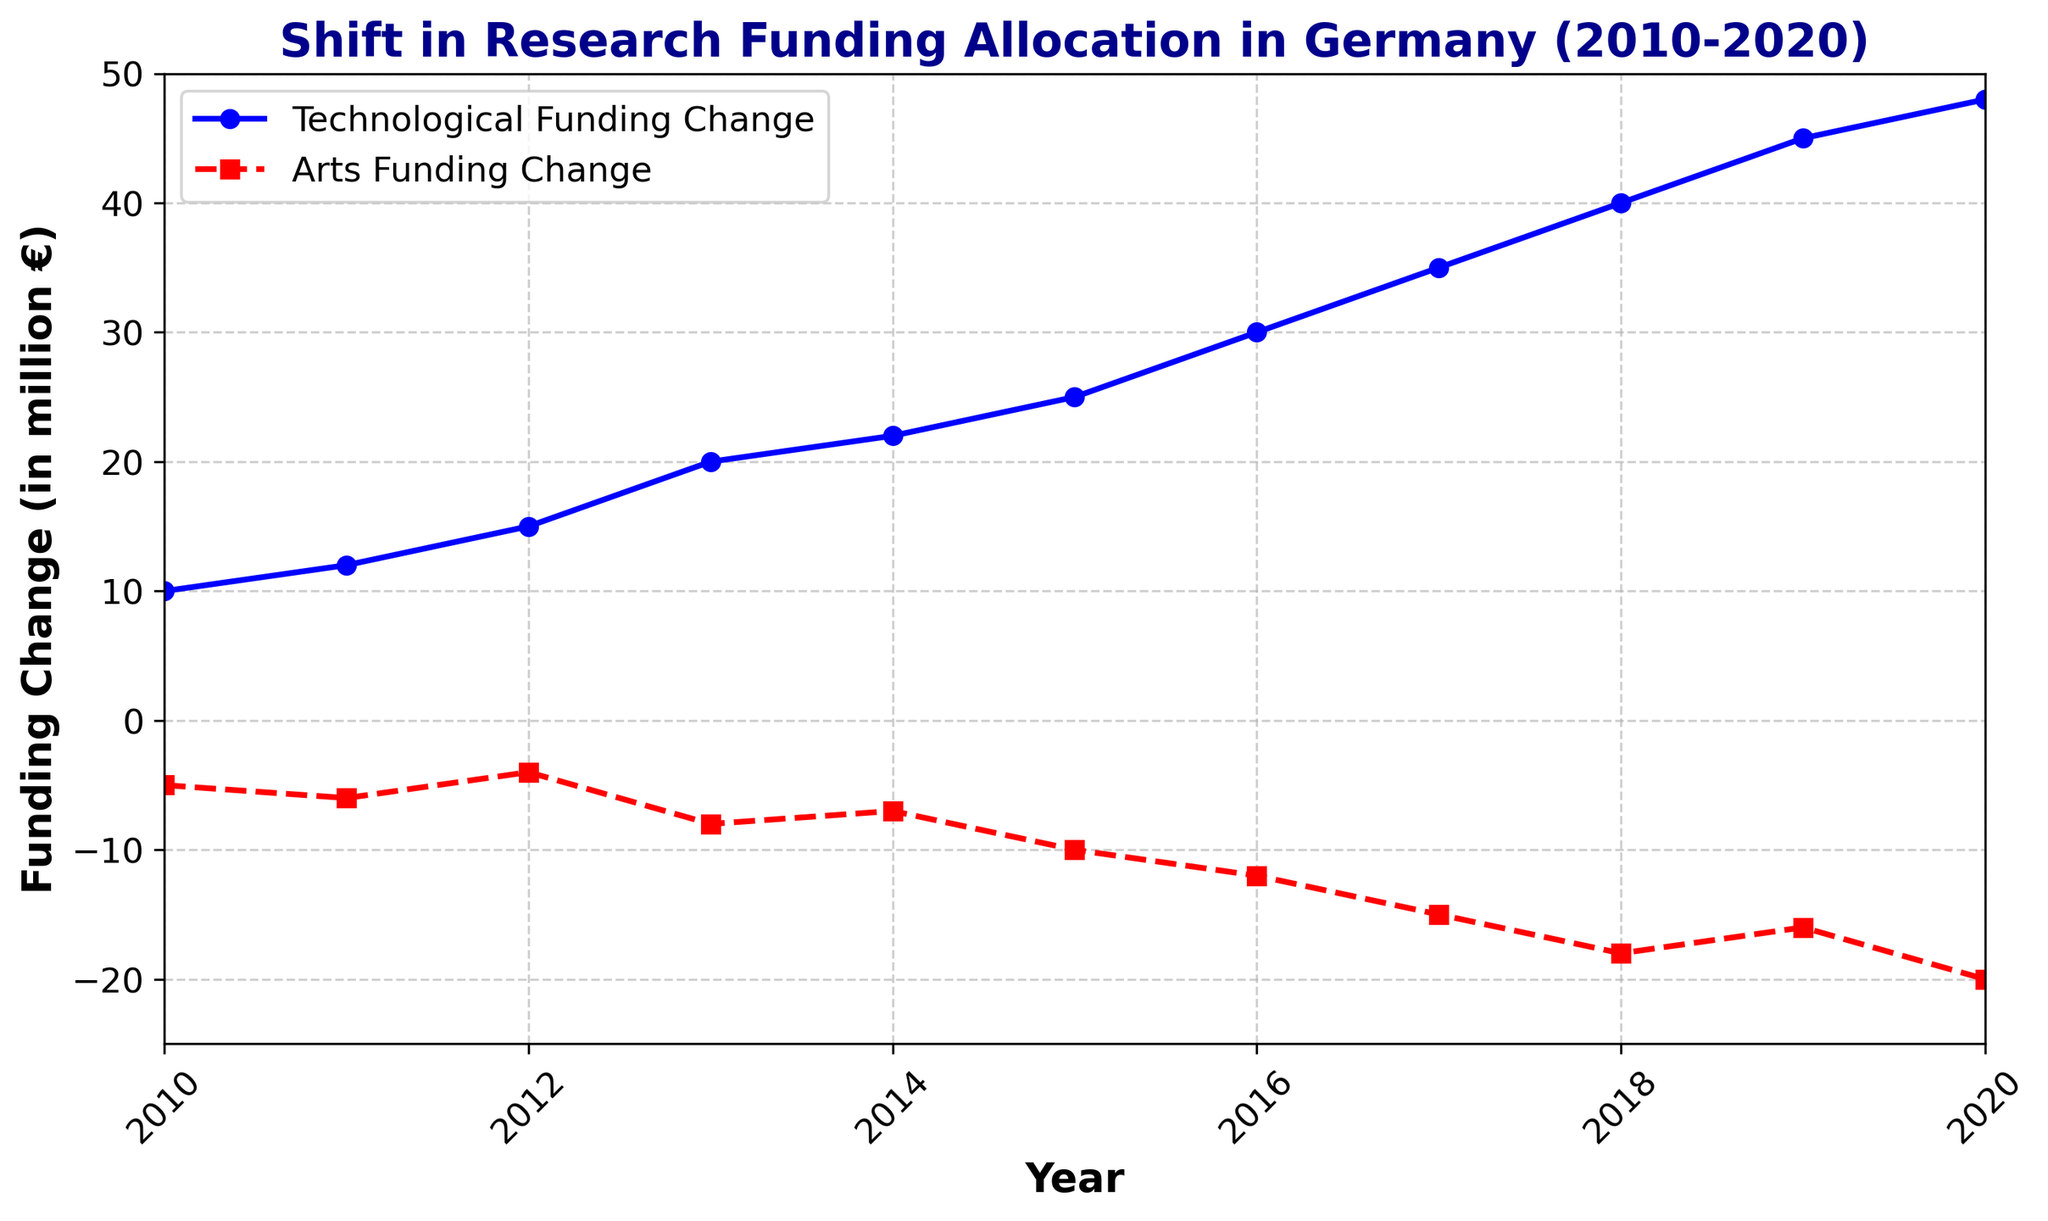What is the trend in Technological Funding Change from 2010 to 2020? The Technological Funding Change shows a consistent upward trend, starting from 10 million € in 2010 to 48 million € in 2020.
Answer: Increasing How does the Arts Funding Change in 2016 compare to that in 2020? In 2016, the Arts Funding Change is -12 million €, while in 2020, it is -20 million €. The funding for Arts projects has decreased more significantly by 2020.
Answer: Decreased Which year saw the greatest change in Technological Funding? By looking at the slope of the blue line, the greatest change in Technological Funding occurred between 2017 and 2018, where the funding increased from 35 million € to 40 million €.
Answer: 2017 to 2018 What is the difference in Technological Funding Change between 2015 and 2020? Technological Funding Change in 2015 is 25 million €, and in 2020, it is 48 million €. The difference is 48 - 25 = 23 million €.
Answer: 23 million € What is the mean change in Arts Funding Change over the given period? Sum of Arts Funding Change from 2010 to 2020 is (-5 + -6 + -4 + -8 + -7 + -10 + -12 + -15 + -18 + -16 + -20) = -121. There are 11 years in total, so the mean is -121 / 11 ≈ -11 million €.
Answer: -11 million € In which year did the Technological Funding Change surpass 30 million €? The Technological Funding Change surpasses 30 million € in 2016, where it reaches 30 million €.
Answer: 2016 Which funding category shows a sharper decline in later years, and how can this be inferred visually? The Arts Funding Change shows a sharper decline in later years, as indicated by the steeper downward slope of the red dashed line from 2017 to 2020.
Answer: Arts Funding Change How much did the Technological Funding Change increase from 2013 to 2014? In 2013, Technological Funding Change was 20 million €, and in 2014 it was 22 million €. The increase is 22 - 20 = 2 million €.
Answer: 2 million € Between which consecutive years did the Arts Funding Change experience the largest decrease? The largest decrease in Arts Funding Change happens between 2017 and 2018, where the change goes from -15 million € to -18 million €, a decrease of 3 million €.
Answer: 2017 to 2018 Compare the total change in funding for Technological projects with the total change for Arts projects between 2010 and 2020. Total Technological Funding Change is (10 + 12 + 15 + 20 + 22 + 25 + 30 + 35 + 40 + 45 + 48) = 302 million €, and Total Arts Funding Change is (-5 + -6 + -4 + -8 + -7 + -10 + -12 + -15 + -18 + -16 + -20) = -121 million €.
Answer: 302 million € vs -121 million € 